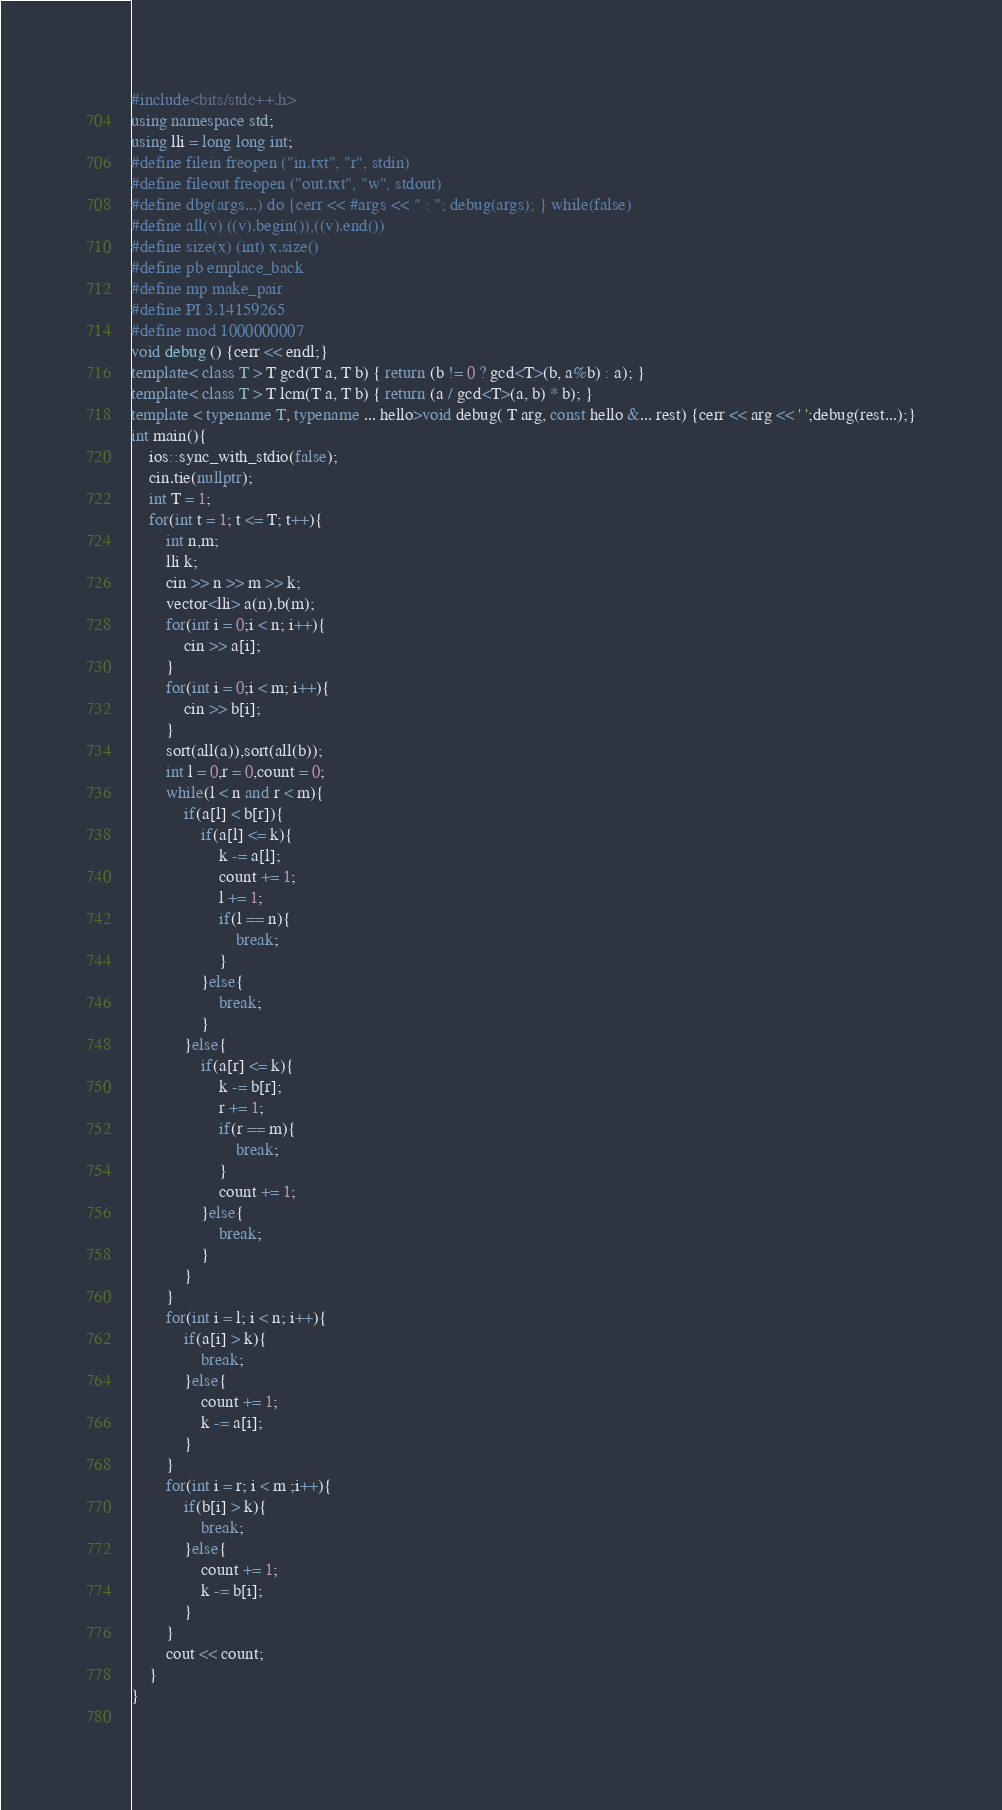<code> <loc_0><loc_0><loc_500><loc_500><_C++_>#include<bits/stdc++.h>
using namespace std;
using lli = long long int;
#define filein freopen ("in.txt", "r", stdin)
#define fileout freopen ("out.txt", "w", stdout)
#define dbg(args...) do {cerr << #args << " : "; debug(args); } while(false)
#define all(v) ((v).begin()),((v).end())
#define size(x) (int) x.size() 
#define pb emplace_back
#define mp make_pair
#define PI 3.14159265
#define mod 1000000007
void debug () {cerr << endl;}
template< class T > T gcd(T a, T b) { return (b != 0 ? gcd<T>(b, a%b) : a); }
template< class T > T lcm(T a, T b) { return (a / gcd<T>(a, b) * b); }
template < typename T, typename ... hello>void debug( T arg, const hello &... rest) {cerr << arg << ' ';debug(rest...);}
int main(){
	ios::sync_with_stdio(false);
    cin.tie(nullptr);
    int T = 1;
    for(int t = 1; t <= T; t++){
		int n,m;
		lli k;
		cin >> n >> m >> k;
		vector<lli> a(n),b(m);
		for(int i = 0;i < n; i++){
			cin >> a[i];
		}
		for(int i = 0;i < m; i++){
			cin >> b[i];
		}
		sort(all(a)),sort(all(b));
		int l = 0,r = 0,count = 0;
		while(l < n and r < m){
			if(a[l] < b[r]){
				if(a[l] <= k){
					k -= a[l];
					count += 1;
					l += 1;
					if(l == n){
						break;
					}
				}else{
					break;
				}
			}else{
				if(a[r] <= k){
					k -= b[r];
					r += 1;
					if(r == m){
						break;
					}
					count += 1;
				}else{
					break;
				}
			}
		}
		for(int i = l; i < n; i++){
			if(a[i] > k){
				break;
			}else{
				count += 1;
				k -= a[i];
			}
		}
		for(int i = r; i < m ;i++){
			if(b[i] > k){
				break;
			}else{
				count += 1;
				k -= b[i];
			}
		}
		cout << count; 
	}
}
 
</code> 